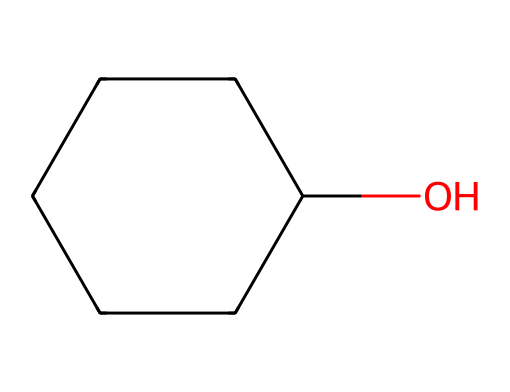What is the molecular formula of cyclohexanol? The structural representation shows one hydroxyl group (OH) and six carbon atoms in a ring (C6). Hence, combining these gives a molecular formula of C6H12O.
Answer: C6H12O How many carbon atoms are in cyclohexanol? From the SMILES representation, there is the notation 'C1CCCCC1', indicating there are six carbon atoms in the cyclic structure.
Answer: 6 What functional group is present in cyclohexanol? The 'O' in the SMILES indicates the presence of an -OH group, which represents a hydroxyl group, a defining feature of alcohols.
Answer: hydroxyl How many hydrogen atoms are associated with each carbon in cyclohexanol? Each carbon in cyclohexanol is tetravalent and in the cyclic structure, generally, two carbon atoms in a cycle can bond with one another, leading to the molecular formula allowing for twelve hydrogens total (C6H12).
Answer: 2 Is cyclohexanol a saturated or unsaturated compound? The presence of only single bonds between carbon atoms in the cycloalkane indicates it is saturated, meaning all available bonding sites are filled with hydrogen atoms.
Answer: saturated What kind of cyclic structure is represented by cyclohexanol? Cyclohexanol has a six-membered ring composed entirely of carbon atoms, specifically forming a cycloalkane.
Answer: cycloalkane 